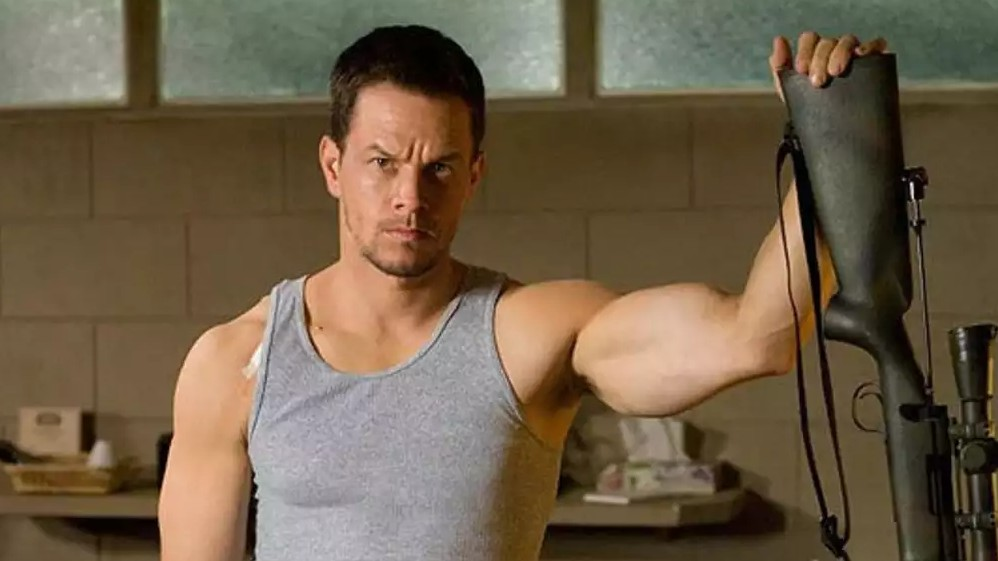Describe a possible backstory for this character. This character could be a former special forces operative who has taken on a mission to protect his family from a looming threat. After years of service, he retired to a quiet life, but recent events have forced him back into action. His serious demeanor and readiness with the rifle suggest he is about to confront a dangerous situation, driven by a personal vendetta or a sense of duty to safeguard his loved ones. 